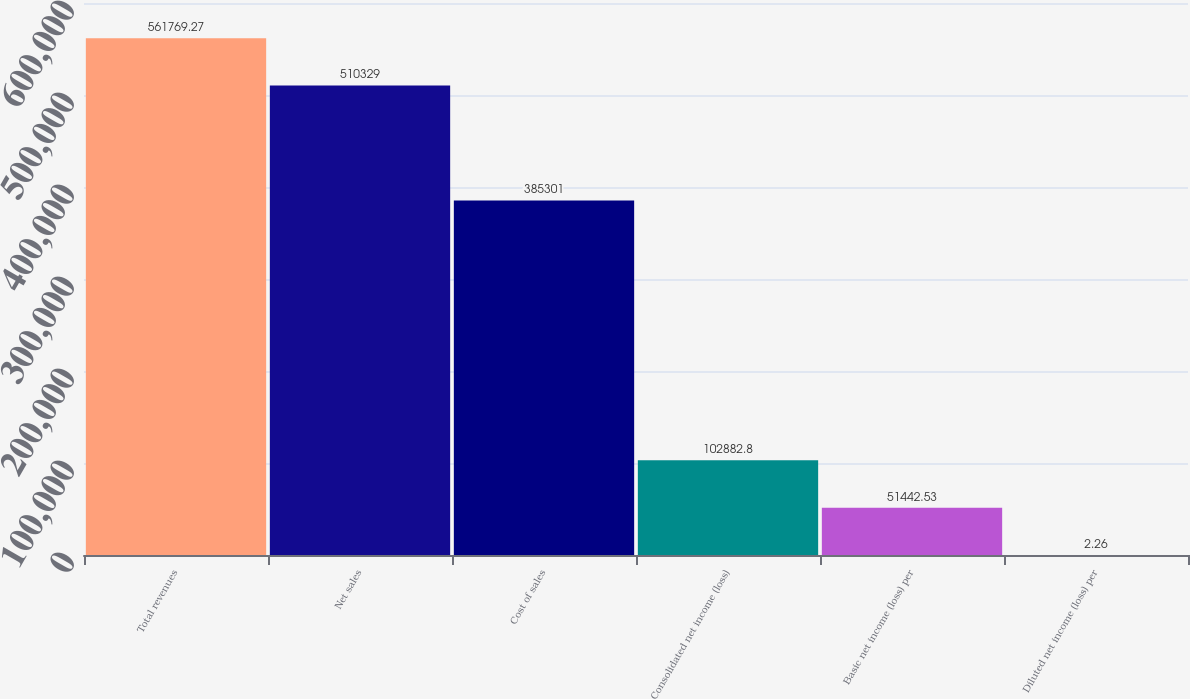Convert chart to OTSL. <chart><loc_0><loc_0><loc_500><loc_500><bar_chart><fcel>Total revenues<fcel>Net sales<fcel>Cost of sales<fcel>Consolidated net income (loss)<fcel>Basic net income (loss) per<fcel>Diluted net income (loss) per<nl><fcel>561769<fcel>510329<fcel>385301<fcel>102883<fcel>51442.5<fcel>2.26<nl></chart> 